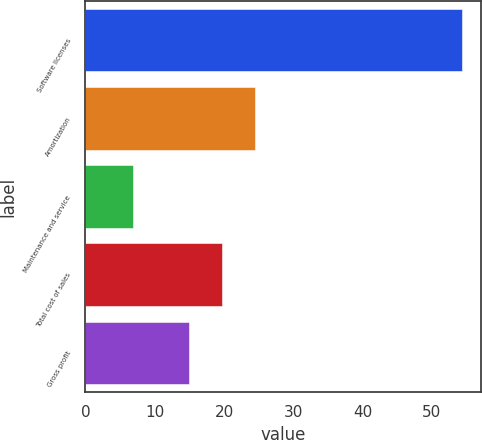<chart> <loc_0><loc_0><loc_500><loc_500><bar_chart><fcel>Software licenses<fcel>Amortization<fcel>Maintenance and service<fcel>Total cost of sales<fcel>Gross profit<nl><fcel>54.3<fcel>24.5<fcel>6.8<fcel>19.75<fcel>15<nl></chart> 